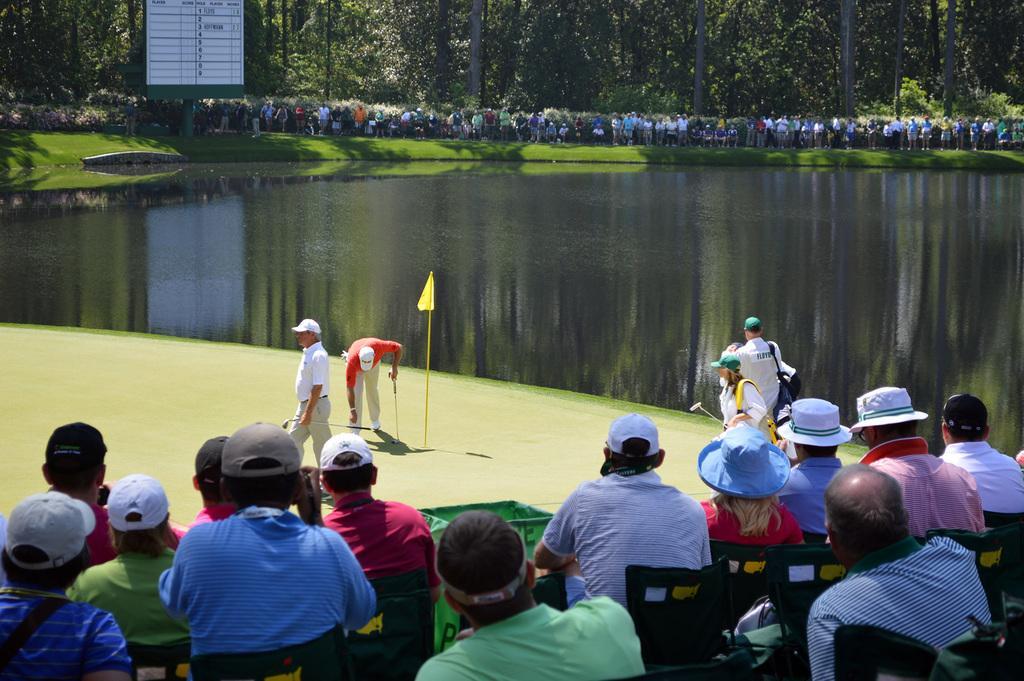Describe this image in one or two sentences. In this image there are people sitting on chairs, in front of them there are golf players standing and there is a flag, in the background there is a pond and people standing near the pond and there are trees and a board on that board there is text. 